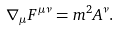<formula> <loc_0><loc_0><loc_500><loc_500>\nabla _ { \mu } F ^ { \mu \nu } = m ^ { 2 } A ^ { \nu } .</formula> 